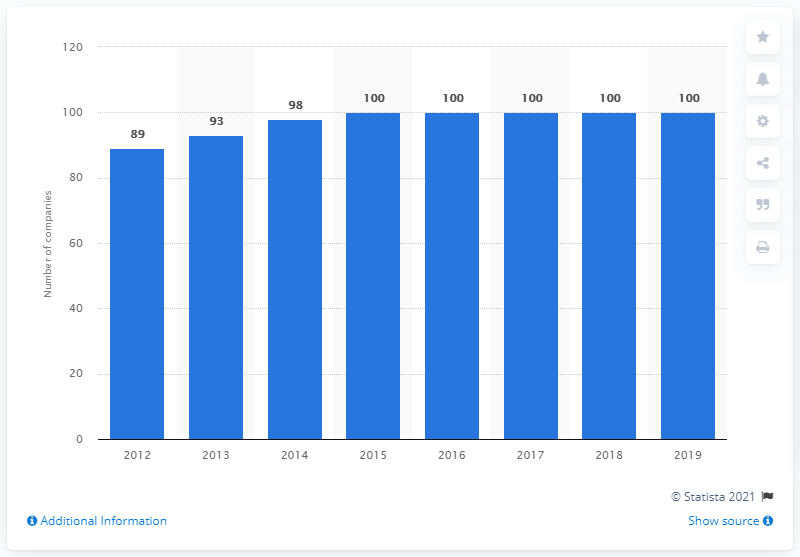Identify some key points in this picture. In 2012, the number of FTSE 100 companies with at least one female director increased. From 2012 to 2019, there have been 100 companies with at least one female director in the United Kingdom (UK) for a total of 7 years. In 2012, there were the lowest number of FTSE 100 companies with at least one female director in the United Kingdom (UK). 